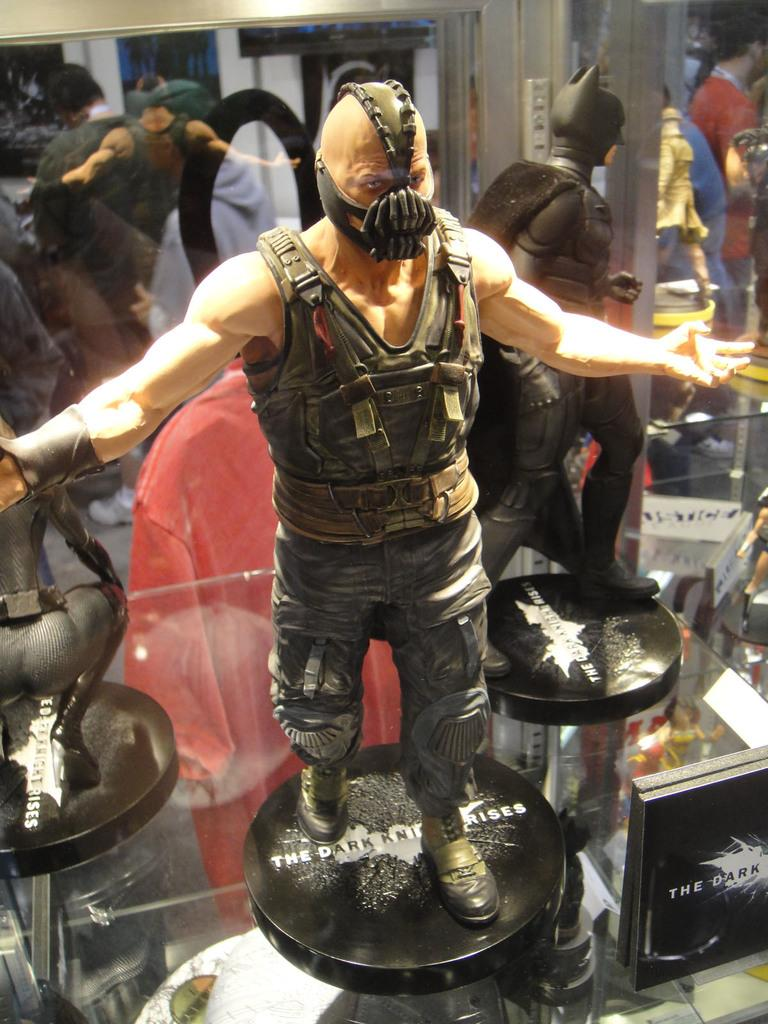What objects are present in the image? There are toys in the image. Where are the toys located? The toys are inside a glass box. Can you see any people in the image? Yes, there are people visible behind the glass. What type of bell can be heard ringing in the image? There is no bell present in the image, and therefore no sound can be heard. 